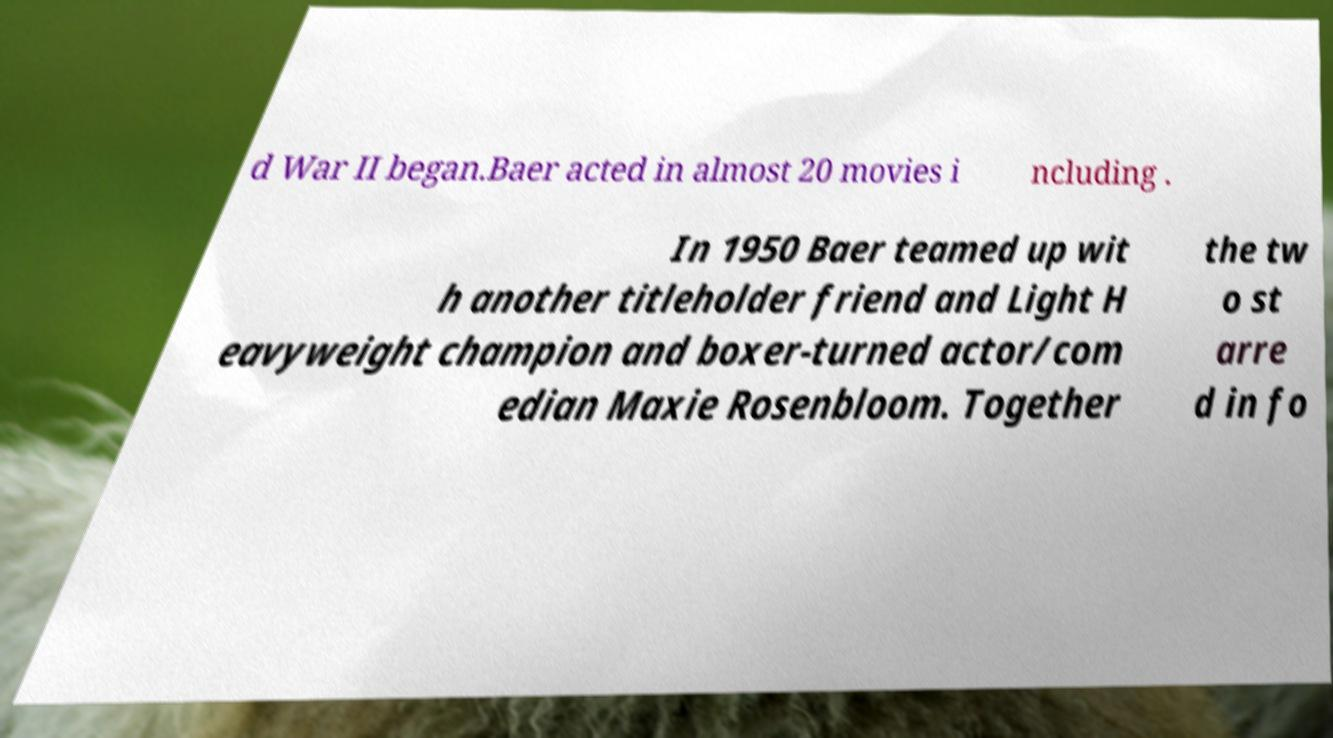For documentation purposes, I need the text within this image transcribed. Could you provide that? d War II began.Baer acted in almost 20 movies i ncluding . In 1950 Baer teamed up wit h another titleholder friend and Light H eavyweight champion and boxer-turned actor/com edian Maxie Rosenbloom. Together the tw o st arre d in fo 